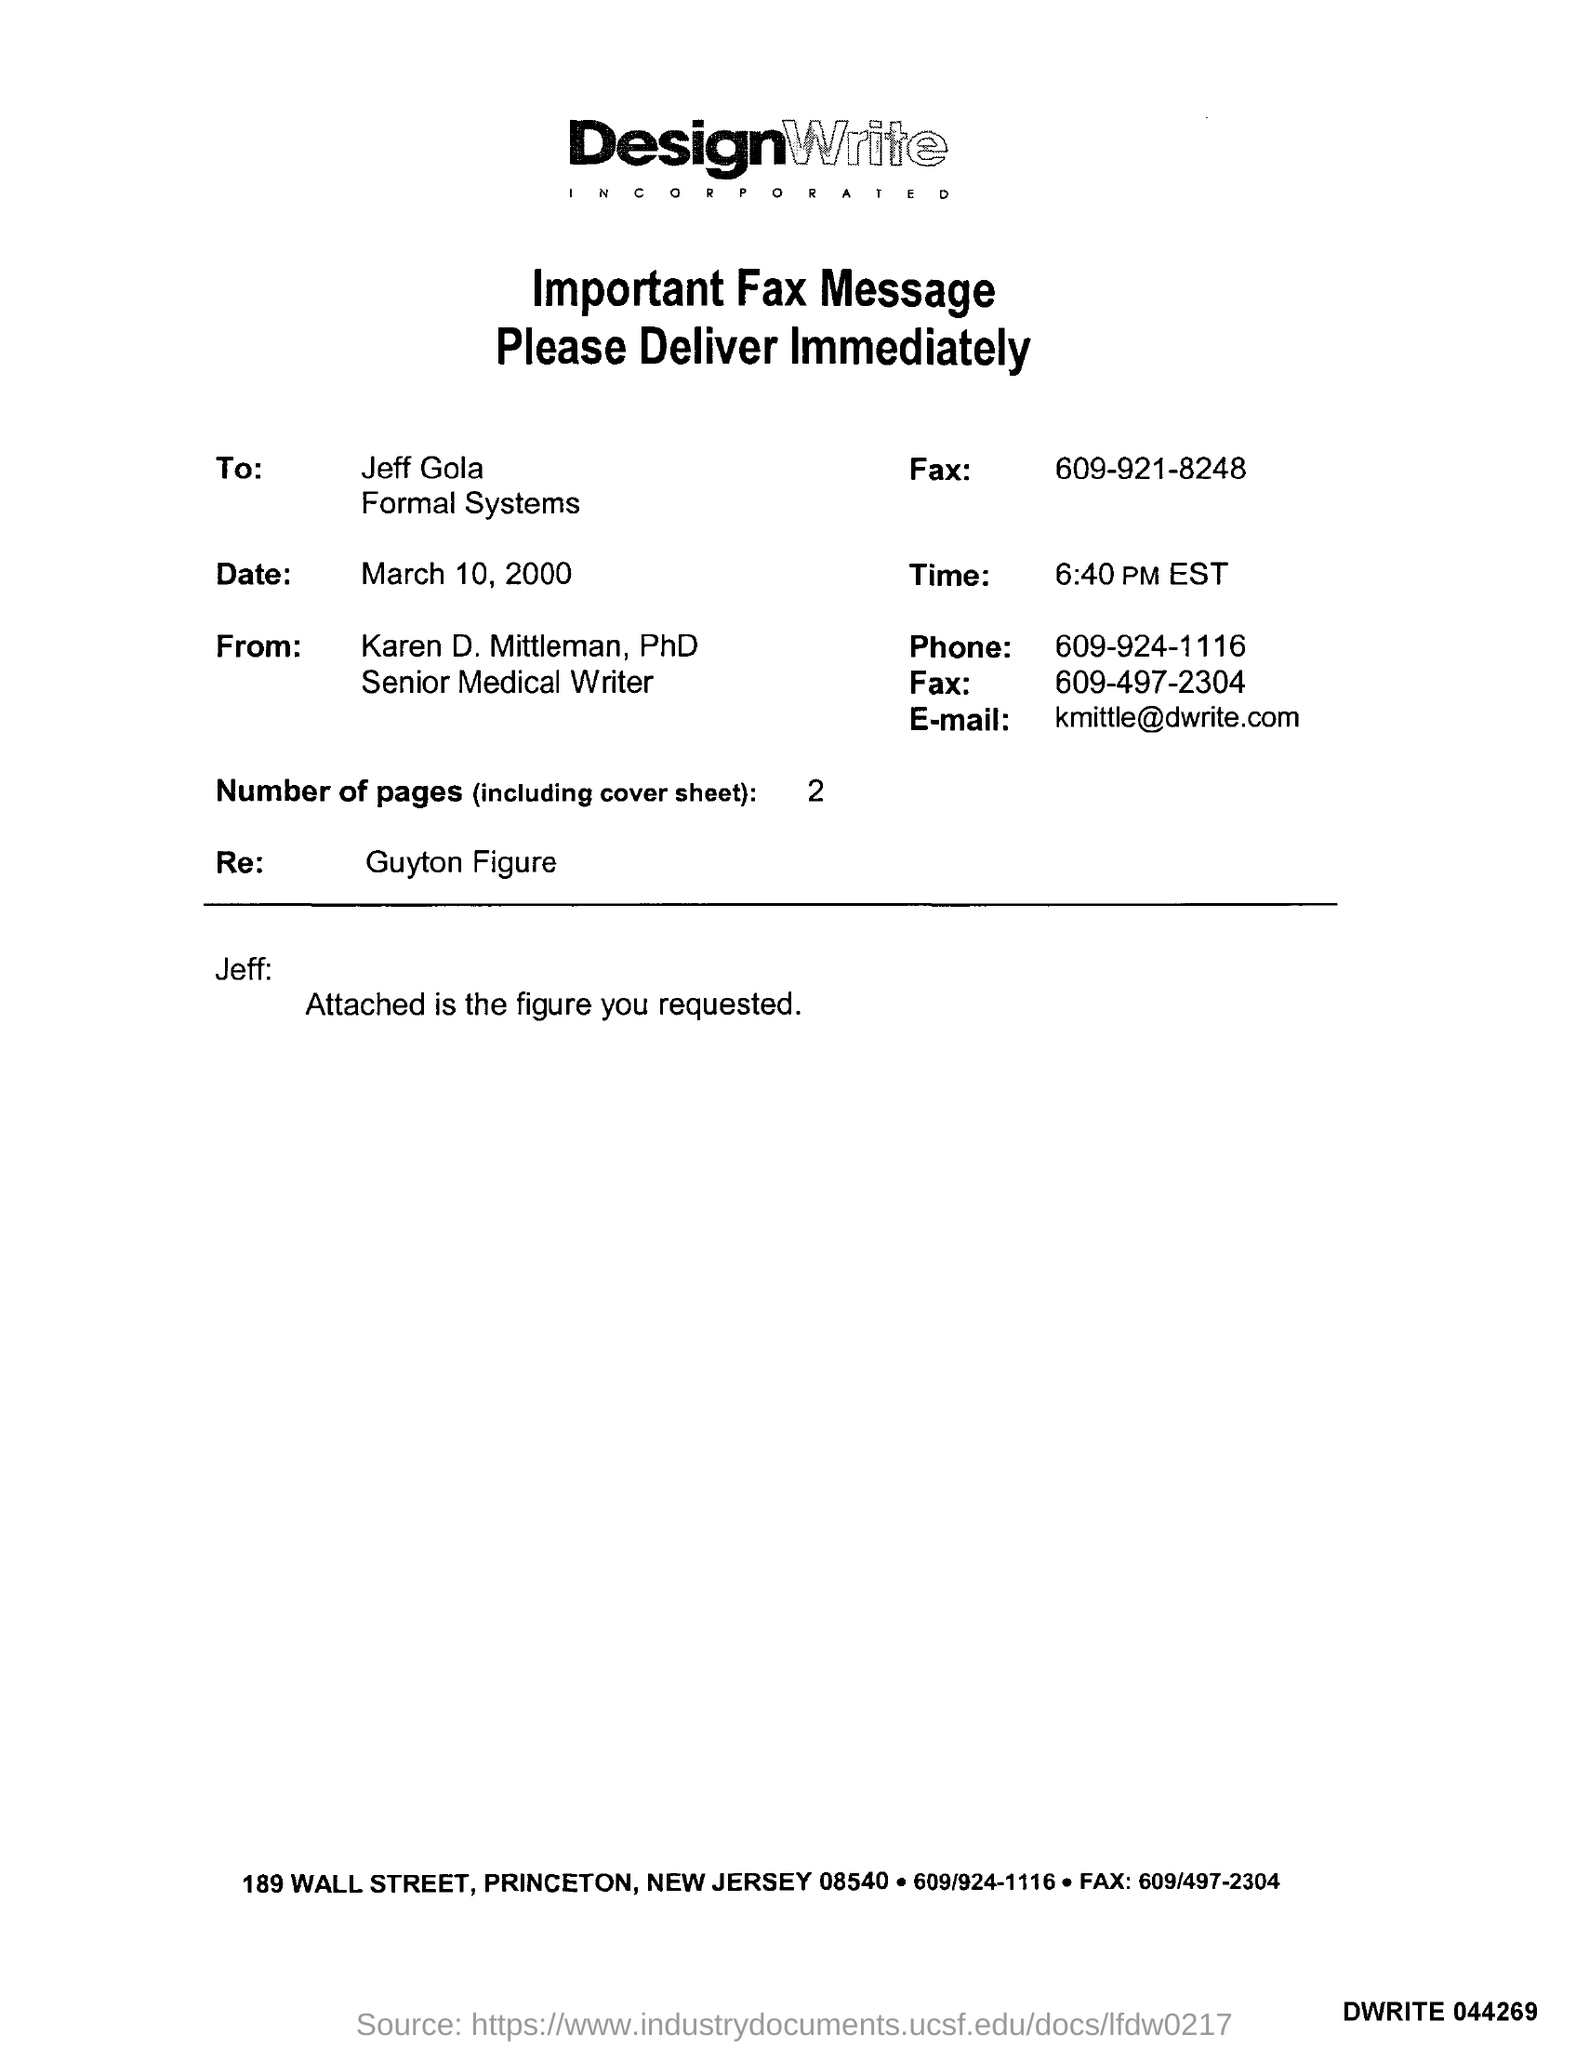To whom this fax was sent ?
Give a very brief answer. Jeff gola. What is the date mentioned in the fax message ?
Offer a very short reply. March 10 , 2000. How many number of pages are there (including cover sheet )?
Your answer should be very brief. 2. What is the time mentioned in the given fax message ?
Your answer should be compact. 6:40 pm EST. From whom this fax message was delivered ?
Provide a succinct answer. Karen D. Mittleman, PhD. What is the phone number mentioned in the fax ?
Your answer should be compact. 609-924-1116. What is re : mentioned in the fax message ?
Offer a very short reply. Guyton Figure. 